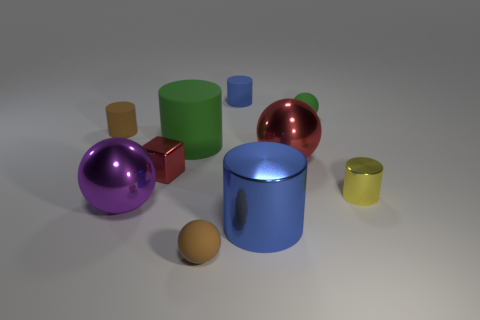Is there a purple ball behind the tiny matte cylinder in front of the tiny blue matte cylinder?
Offer a very short reply. No. How many things are large things in front of the yellow cylinder or large cylinders that are to the left of the small blue cylinder?
Provide a succinct answer. 3. Is there anything else of the same color as the tiny block?
Your answer should be very brief. Yes. What is the color of the large ball that is on the left side of the blue cylinder that is behind the tiny cylinder in front of the small brown matte cylinder?
Your answer should be compact. Purple. There is a metal object that is behind the tiny metal block left of the tiny brown rubber sphere; what size is it?
Offer a terse response. Large. There is a tiny thing that is to the left of the small yellow metal object and in front of the small shiny cube; what is it made of?
Give a very brief answer. Rubber. Does the yellow metal cylinder have the same size as the red cube that is to the left of the blue shiny object?
Your response must be concise. Yes. Is there a blue cylinder?
Your answer should be compact. Yes. There is a red object that is the same shape as the tiny green rubber thing; what is its material?
Provide a short and direct response. Metal. There is a blue thing that is in front of the brown thing behind the tiny matte thing in front of the tiny yellow metallic cylinder; what is its size?
Your answer should be very brief. Large. 